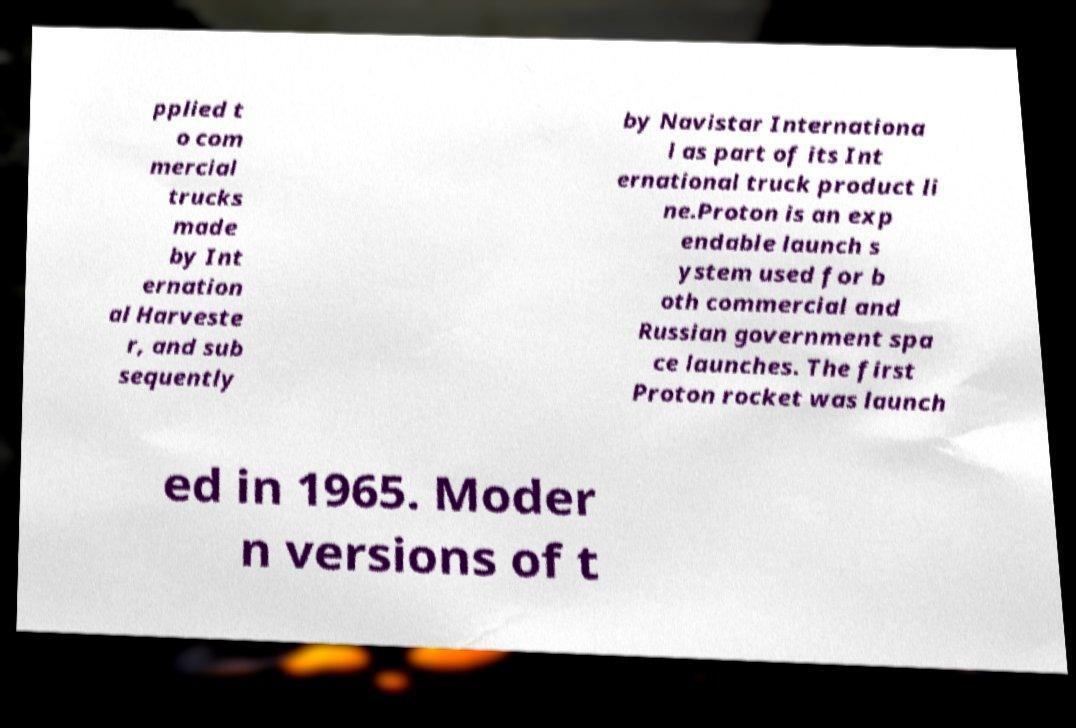Can you accurately transcribe the text from the provided image for me? pplied t o com mercial trucks made by Int ernation al Harveste r, and sub sequently by Navistar Internationa l as part of its Int ernational truck product li ne.Proton is an exp endable launch s ystem used for b oth commercial and Russian government spa ce launches. The first Proton rocket was launch ed in 1965. Moder n versions of t 